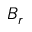Convert formula to latex. <formula><loc_0><loc_0><loc_500><loc_500>B _ { r }</formula> 